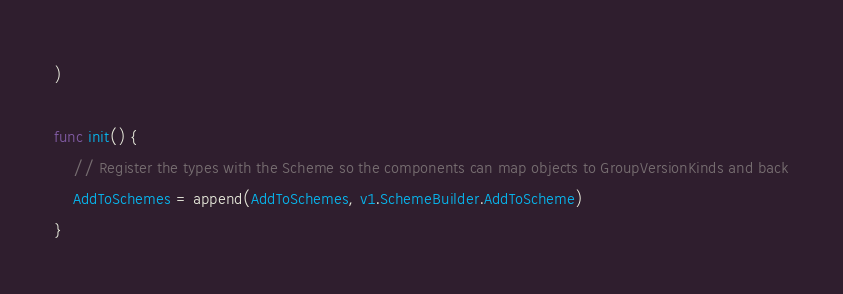<code> <loc_0><loc_0><loc_500><loc_500><_Go_>)

func init() {
	// Register the types with the Scheme so the components can map objects to GroupVersionKinds and back
	AddToSchemes = append(AddToSchemes, v1.SchemeBuilder.AddToScheme)
}
</code> 